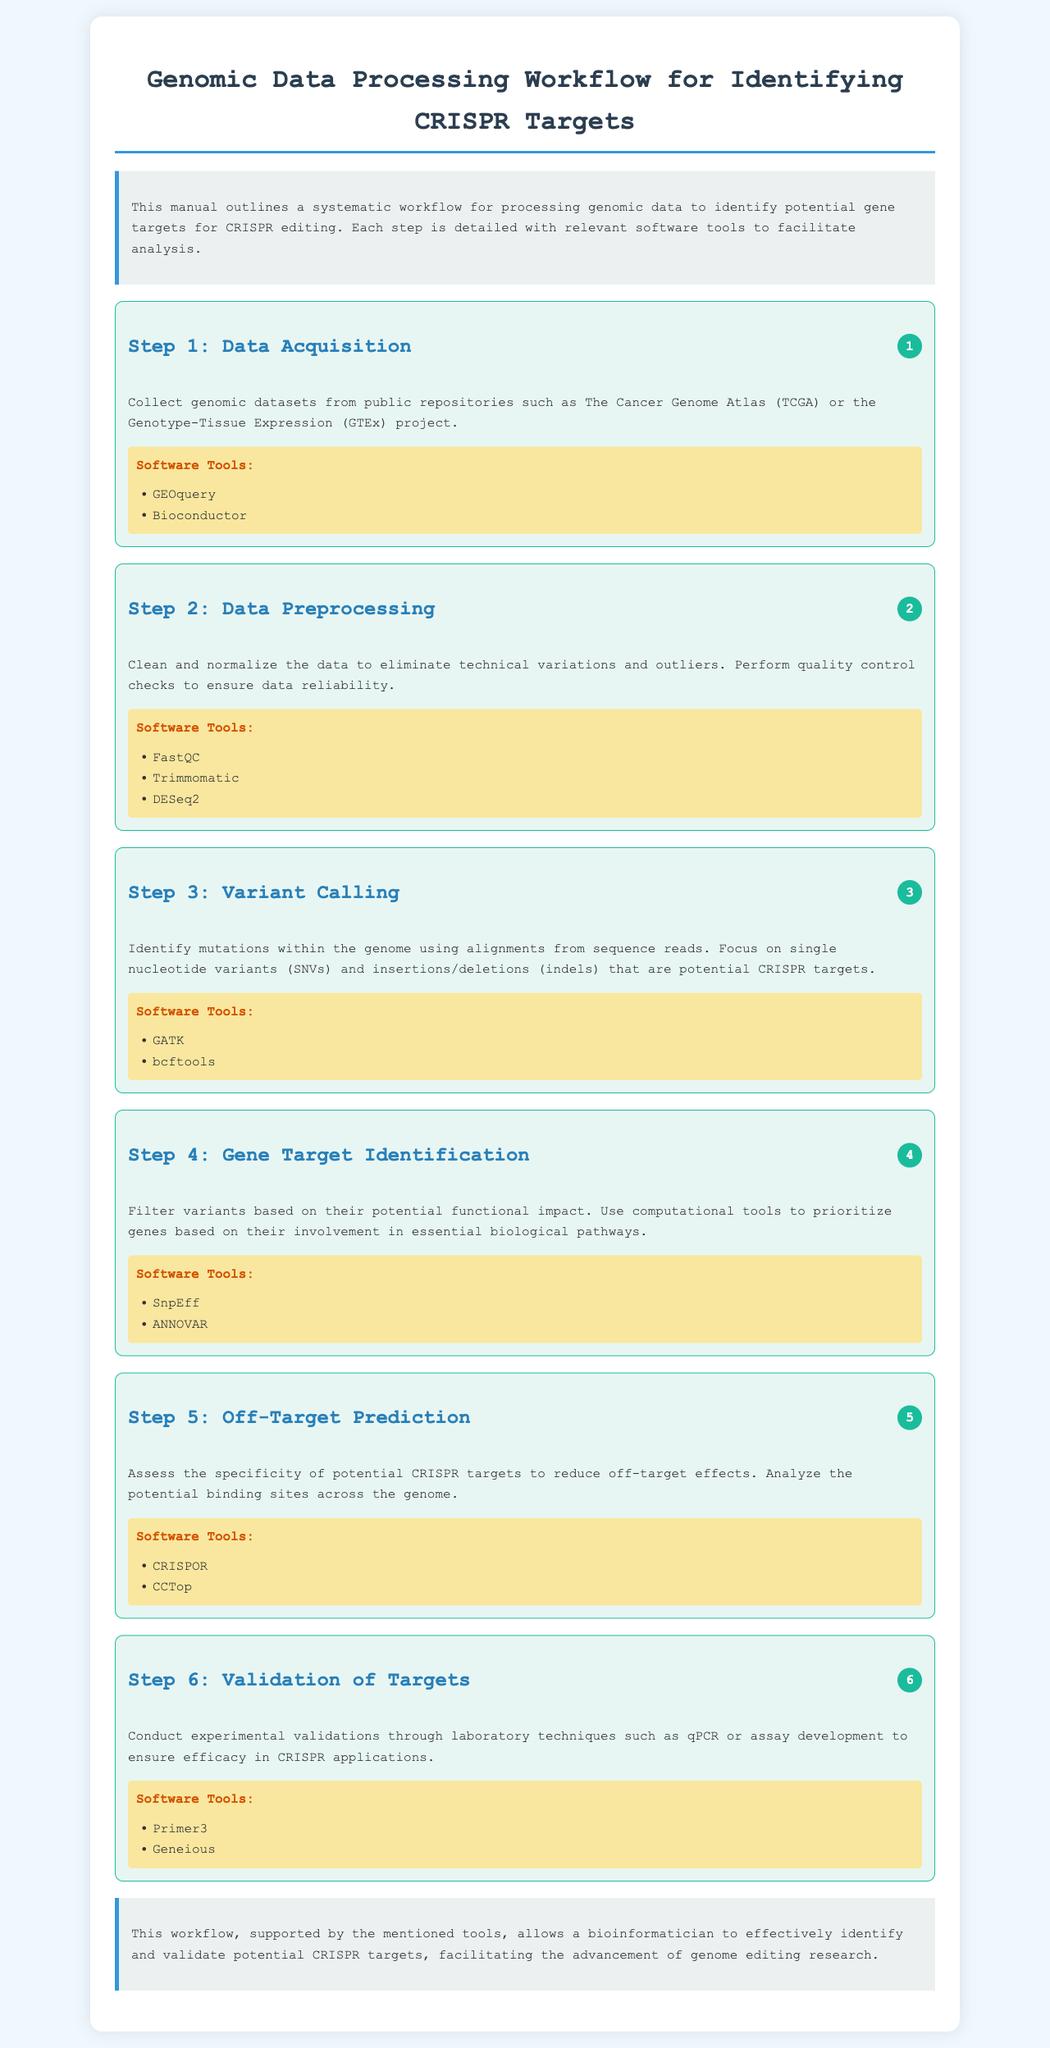What is the first step in the workflow? The first step in the workflow is outlined in the first workflow step, which is Data Acquisition.
Answer: Data Acquisition Which software tools are recommended for Data Preprocessing? In the document, the second workflow step details the tools used for Data Preprocessing, which are FastQC, Trimmomatic, and DESeq2.
Answer: FastQC, Trimmomatic, DESeq2 What is the focus of Step 3? Step 3 discusses the identification of mutations, specifically focusing on single nucleotide variants and insertions/deletions.
Answer: Single nucleotide variants and insertions/deletions Which tool is used for Off-Target Prediction? In Step 5, the document lists CRISPOR and CCTop as tools for Off-Target Prediction.
Answer: CRISPOR How many steps are there in the workflow? The document outlines a total of six steps in the genomic data processing workflow.
Answer: Six What is the purpose of Step 6? The sixth step focuses on conducting experimental validations through laboratory techniques to ensure efficacy in CRISPR applications.
Answer: Experimental validations Which project is mentioned for Data Acquisition? The document mentions The Cancer Genome Atlas as a source for collecting genomic datasets during Data Acquisition.
Answer: The Cancer Genome Atlas What kind of variants are prioritized in Step 4? Step 4 prioritizes variants based on their potential functional impact and involvement in essential biological pathways.
Answer: Functional impact and essential biological pathways What is the conclusion about the workflow? The conclusion summarizes that the workflow allows a bioinformatician to effectively identify and validate potential CRISPR targets.
Answer: Identify and validate potential CRISPR targets 